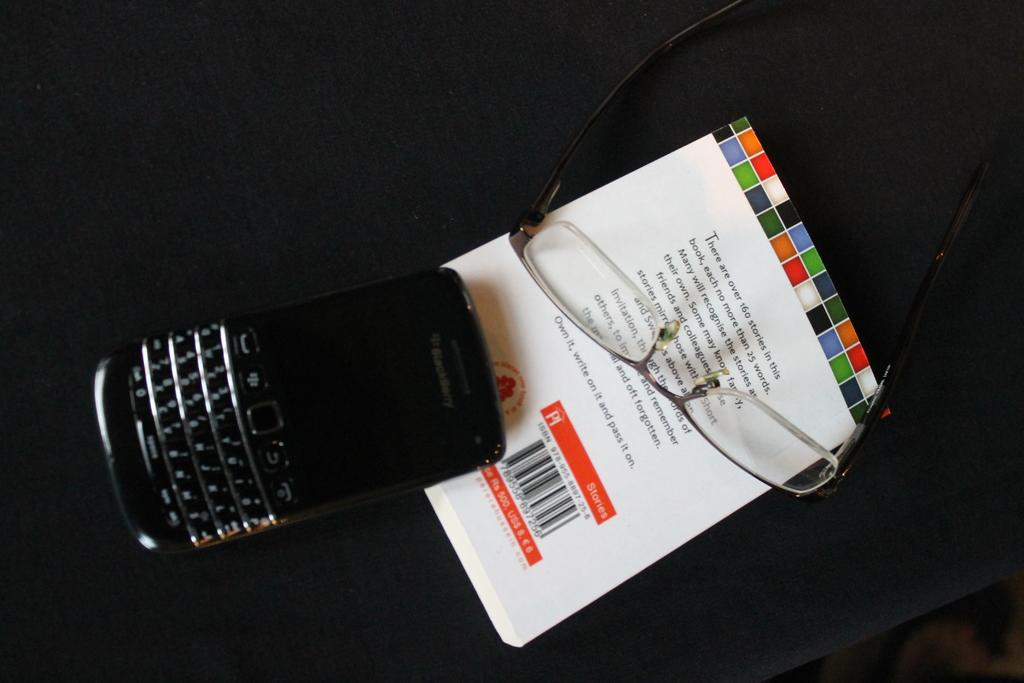<image>
Present a compact description of the photo's key features. a black blackberry phone on top of a booklet with glasses 